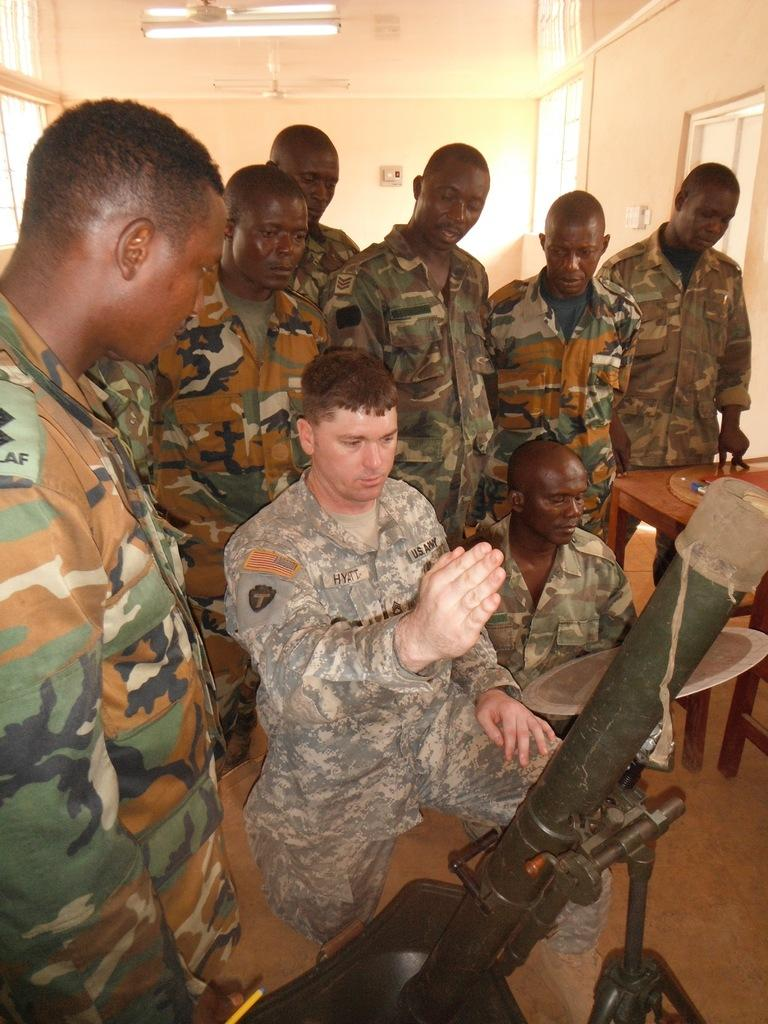What is the main subject of the image? The main subject of the image is a group of people standing together. What can be seen in the image besides the group of people? There is a military weapon and a table with a light on top in the image. What are the people in the group wearing? The people in the group are wearing military dress. How does the group of people start a clam farm in the image? There is no mention of a clam farm or any farming activity in the image. The image features a group of people standing together, a military weapon, and a table with a light on top. 